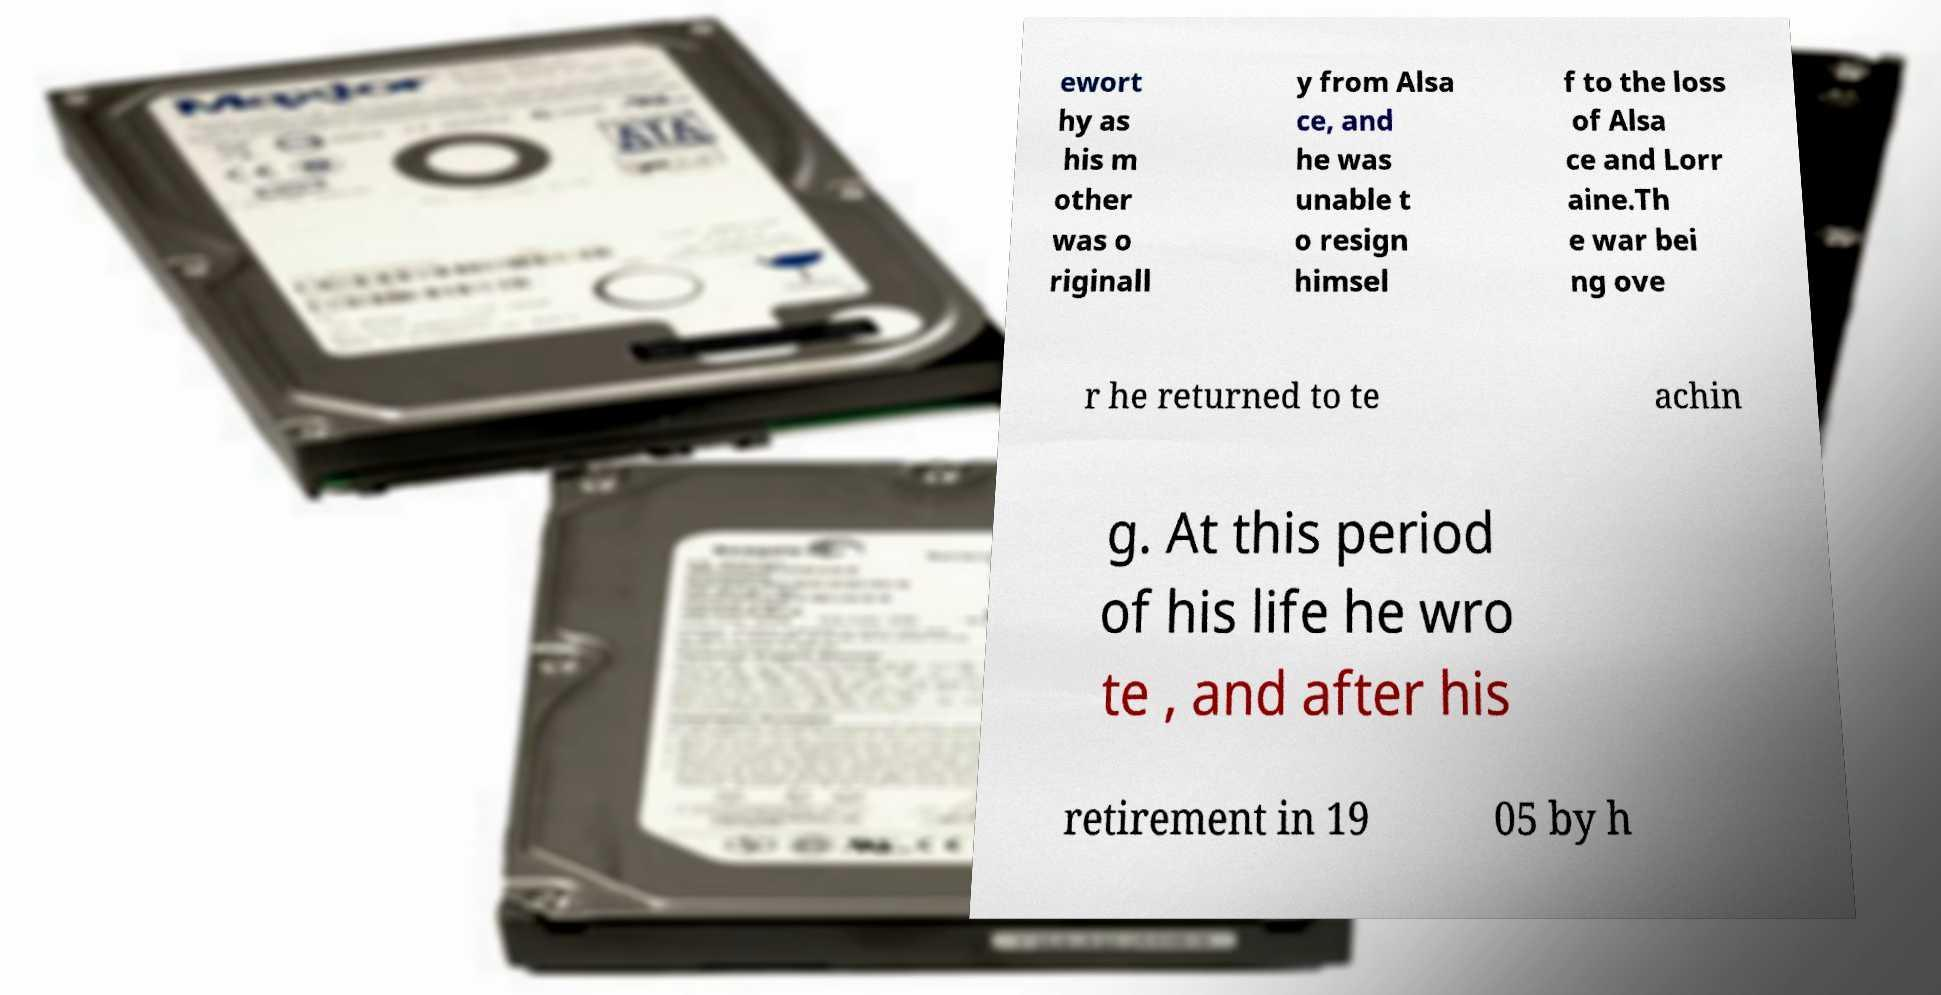Please identify and transcribe the text found in this image. ewort hy as his m other was o riginall y from Alsa ce, and he was unable t o resign himsel f to the loss of Alsa ce and Lorr aine.Th e war bei ng ove r he returned to te achin g. At this period of his life he wro te , and after his retirement in 19 05 by h 